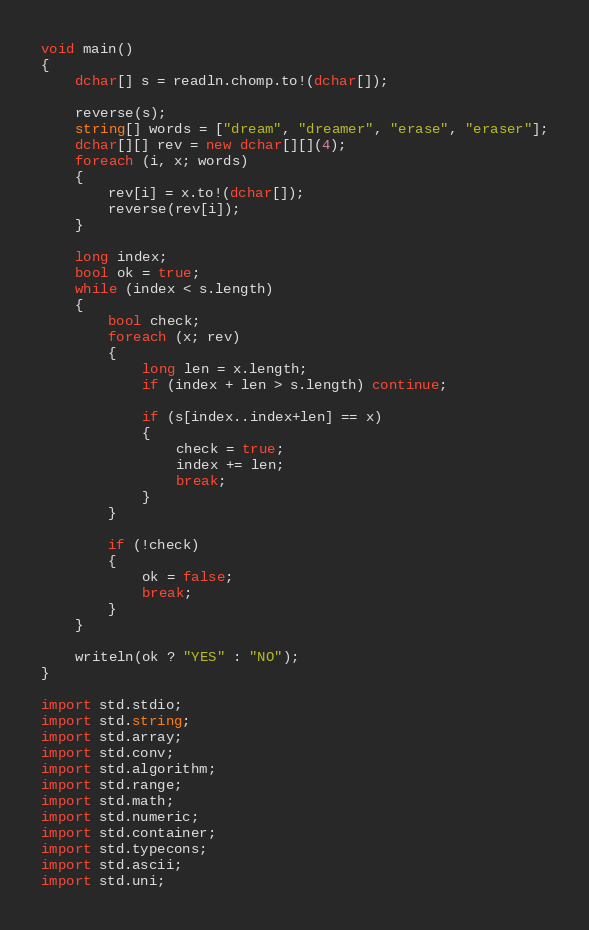<code> <loc_0><loc_0><loc_500><loc_500><_D_>void main()
{
    dchar[] s = readln.chomp.to!(dchar[]);

    reverse(s);
    string[] words = ["dream", "dreamer", "erase", "eraser"];
    dchar[][] rev = new dchar[][](4);
    foreach (i, x; words)
    {
        rev[i] = x.to!(dchar[]);
        reverse(rev[i]);
    }

    long index;
    bool ok = true;
    while (index < s.length)
    {
        bool check;
        foreach (x; rev)
        {
            long len = x.length;
            if (index + len > s.length) continue;

            if (s[index..index+len] == x)
            {
                check = true;
                index += len;
                break;
            }
        }

        if (!check)
        {
            ok = false;
            break;
        }
    }

    writeln(ok ? "YES" : "NO");
}

import std.stdio;
import std.string;
import std.array;
import std.conv;
import std.algorithm;
import std.range;
import std.math;
import std.numeric;
import std.container;
import std.typecons;
import std.ascii;
import std.uni;</code> 